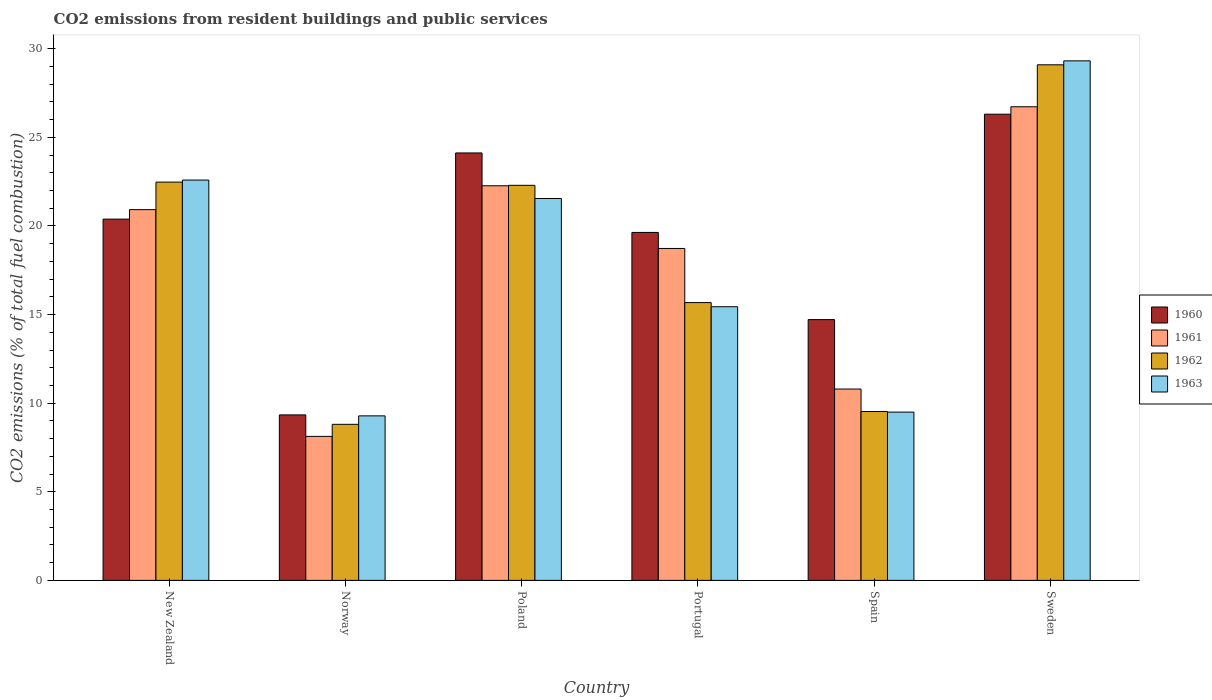Are the number of bars per tick equal to the number of legend labels?
Your answer should be very brief. Yes. Are the number of bars on each tick of the X-axis equal?
Make the answer very short. Yes. How many bars are there on the 6th tick from the right?
Your response must be concise. 4. What is the label of the 2nd group of bars from the left?
Keep it short and to the point. Norway. What is the total CO2 emitted in 1963 in Portugal?
Offer a terse response. 15.44. Across all countries, what is the maximum total CO2 emitted in 1963?
Provide a succinct answer. 29.32. Across all countries, what is the minimum total CO2 emitted in 1963?
Keep it short and to the point. 9.28. In which country was the total CO2 emitted in 1960 maximum?
Offer a terse response. Sweden. What is the total total CO2 emitted in 1962 in the graph?
Ensure brevity in your answer.  107.89. What is the difference between the total CO2 emitted in 1960 in Norway and that in Spain?
Keep it short and to the point. -5.38. What is the difference between the total CO2 emitted in 1962 in Sweden and the total CO2 emitted in 1960 in Poland?
Make the answer very short. 4.97. What is the average total CO2 emitted in 1962 per country?
Your answer should be very brief. 17.98. What is the difference between the total CO2 emitted of/in 1960 and total CO2 emitted of/in 1963 in Spain?
Ensure brevity in your answer.  5.22. In how many countries, is the total CO2 emitted in 1961 greater than 17?
Ensure brevity in your answer.  4. What is the ratio of the total CO2 emitted in 1960 in New Zealand to that in Poland?
Keep it short and to the point. 0.85. Is the difference between the total CO2 emitted in 1960 in New Zealand and Portugal greater than the difference between the total CO2 emitted in 1963 in New Zealand and Portugal?
Provide a short and direct response. No. What is the difference between the highest and the second highest total CO2 emitted in 1963?
Keep it short and to the point. -7.77. What is the difference between the highest and the lowest total CO2 emitted in 1960?
Your answer should be compact. 16.97. In how many countries, is the total CO2 emitted in 1961 greater than the average total CO2 emitted in 1961 taken over all countries?
Provide a short and direct response. 4. Is the sum of the total CO2 emitted in 1962 in Norway and Portugal greater than the maximum total CO2 emitted in 1960 across all countries?
Provide a succinct answer. No. Is it the case that in every country, the sum of the total CO2 emitted in 1960 and total CO2 emitted in 1963 is greater than the sum of total CO2 emitted in 1962 and total CO2 emitted in 1961?
Your response must be concise. No. What does the 4th bar from the left in Sweden represents?
Your answer should be very brief. 1963. What does the 1st bar from the right in Portugal represents?
Ensure brevity in your answer.  1963. How many countries are there in the graph?
Ensure brevity in your answer.  6. What is the difference between two consecutive major ticks on the Y-axis?
Make the answer very short. 5. Does the graph contain any zero values?
Keep it short and to the point. No. What is the title of the graph?
Keep it short and to the point. CO2 emissions from resident buildings and public services. What is the label or title of the X-axis?
Your answer should be very brief. Country. What is the label or title of the Y-axis?
Offer a very short reply. CO2 emissions (% of total fuel combustion). What is the CO2 emissions (% of total fuel combustion) in 1960 in New Zealand?
Your answer should be very brief. 20.39. What is the CO2 emissions (% of total fuel combustion) in 1961 in New Zealand?
Provide a succinct answer. 20.92. What is the CO2 emissions (% of total fuel combustion) of 1962 in New Zealand?
Give a very brief answer. 22.48. What is the CO2 emissions (% of total fuel combustion) in 1963 in New Zealand?
Make the answer very short. 22.59. What is the CO2 emissions (% of total fuel combustion) of 1960 in Norway?
Provide a short and direct response. 9.34. What is the CO2 emissions (% of total fuel combustion) of 1961 in Norway?
Keep it short and to the point. 8.13. What is the CO2 emissions (% of total fuel combustion) of 1962 in Norway?
Provide a succinct answer. 8.81. What is the CO2 emissions (% of total fuel combustion) in 1963 in Norway?
Offer a very short reply. 9.28. What is the CO2 emissions (% of total fuel combustion) of 1960 in Poland?
Offer a terse response. 24.12. What is the CO2 emissions (% of total fuel combustion) in 1961 in Poland?
Give a very brief answer. 22.27. What is the CO2 emissions (% of total fuel combustion) in 1962 in Poland?
Give a very brief answer. 22.3. What is the CO2 emissions (% of total fuel combustion) in 1963 in Poland?
Provide a succinct answer. 21.55. What is the CO2 emissions (% of total fuel combustion) in 1960 in Portugal?
Your answer should be compact. 19.64. What is the CO2 emissions (% of total fuel combustion) in 1961 in Portugal?
Your answer should be compact. 18.73. What is the CO2 emissions (% of total fuel combustion) in 1962 in Portugal?
Your answer should be very brief. 15.68. What is the CO2 emissions (% of total fuel combustion) in 1963 in Portugal?
Your answer should be compact. 15.44. What is the CO2 emissions (% of total fuel combustion) in 1960 in Spain?
Make the answer very short. 14.72. What is the CO2 emissions (% of total fuel combustion) in 1961 in Spain?
Your answer should be compact. 10.8. What is the CO2 emissions (% of total fuel combustion) in 1962 in Spain?
Keep it short and to the point. 9.53. What is the CO2 emissions (% of total fuel combustion) in 1963 in Spain?
Provide a succinct answer. 9.5. What is the CO2 emissions (% of total fuel combustion) of 1960 in Sweden?
Make the answer very short. 26.31. What is the CO2 emissions (% of total fuel combustion) of 1961 in Sweden?
Make the answer very short. 26.73. What is the CO2 emissions (% of total fuel combustion) in 1962 in Sweden?
Keep it short and to the point. 29.1. What is the CO2 emissions (% of total fuel combustion) of 1963 in Sweden?
Provide a succinct answer. 29.32. Across all countries, what is the maximum CO2 emissions (% of total fuel combustion) in 1960?
Make the answer very short. 26.31. Across all countries, what is the maximum CO2 emissions (% of total fuel combustion) in 1961?
Provide a short and direct response. 26.73. Across all countries, what is the maximum CO2 emissions (% of total fuel combustion) in 1962?
Your response must be concise. 29.1. Across all countries, what is the maximum CO2 emissions (% of total fuel combustion) of 1963?
Provide a short and direct response. 29.32. Across all countries, what is the minimum CO2 emissions (% of total fuel combustion) of 1960?
Your answer should be very brief. 9.34. Across all countries, what is the minimum CO2 emissions (% of total fuel combustion) of 1961?
Offer a very short reply. 8.13. Across all countries, what is the minimum CO2 emissions (% of total fuel combustion) of 1962?
Ensure brevity in your answer.  8.81. Across all countries, what is the minimum CO2 emissions (% of total fuel combustion) in 1963?
Give a very brief answer. 9.28. What is the total CO2 emissions (% of total fuel combustion) of 1960 in the graph?
Keep it short and to the point. 114.51. What is the total CO2 emissions (% of total fuel combustion) of 1961 in the graph?
Make the answer very short. 107.58. What is the total CO2 emissions (% of total fuel combustion) in 1962 in the graph?
Make the answer very short. 107.89. What is the total CO2 emissions (% of total fuel combustion) in 1963 in the graph?
Offer a very short reply. 107.69. What is the difference between the CO2 emissions (% of total fuel combustion) of 1960 in New Zealand and that in Norway?
Your answer should be very brief. 11.05. What is the difference between the CO2 emissions (% of total fuel combustion) of 1961 in New Zealand and that in Norway?
Your answer should be very brief. 12.8. What is the difference between the CO2 emissions (% of total fuel combustion) of 1962 in New Zealand and that in Norway?
Offer a terse response. 13.67. What is the difference between the CO2 emissions (% of total fuel combustion) of 1963 in New Zealand and that in Norway?
Provide a succinct answer. 13.31. What is the difference between the CO2 emissions (% of total fuel combustion) in 1960 in New Zealand and that in Poland?
Your answer should be compact. -3.73. What is the difference between the CO2 emissions (% of total fuel combustion) of 1961 in New Zealand and that in Poland?
Offer a terse response. -1.35. What is the difference between the CO2 emissions (% of total fuel combustion) in 1962 in New Zealand and that in Poland?
Provide a succinct answer. 0.18. What is the difference between the CO2 emissions (% of total fuel combustion) in 1963 in New Zealand and that in Poland?
Your answer should be very brief. 1.04. What is the difference between the CO2 emissions (% of total fuel combustion) of 1960 in New Zealand and that in Portugal?
Provide a succinct answer. 0.75. What is the difference between the CO2 emissions (% of total fuel combustion) in 1961 in New Zealand and that in Portugal?
Provide a succinct answer. 2.19. What is the difference between the CO2 emissions (% of total fuel combustion) of 1962 in New Zealand and that in Portugal?
Your answer should be compact. 6.8. What is the difference between the CO2 emissions (% of total fuel combustion) in 1963 in New Zealand and that in Portugal?
Make the answer very short. 7.15. What is the difference between the CO2 emissions (% of total fuel combustion) in 1960 in New Zealand and that in Spain?
Keep it short and to the point. 5.67. What is the difference between the CO2 emissions (% of total fuel combustion) in 1961 in New Zealand and that in Spain?
Your response must be concise. 10.13. What is the difference between the CO2 emissions (% of total fuel combustion) in 1962 in New Zealand and that in Spain?
Your answer should be compact. 12.95. What is the difference between the CO2 emissions (% of total fuel combustion) in 1963 in New Zealand and that in Spain?
Provide a short and direct response. 13.1. What is the difference between the CO2 emissions (% of total fuel combustion) in 1960 in New Zealand and that in Sweden?
Ensure brevity in your answer.  -5.92. What is the difference between the CO2 emissions (% of total fuel combustion) in 1961 in New Zealand and that in Sweden?
Ensure brevity in your answer.  -5.81. What is the difference between the CO2 emissions (% of total fuel combustion) in 1962 in New Zealand and that in Sweden?
Your response must be concise. -6.62. What is the difference between the CO2 emissions (% of total fuel combustion) of 1963 in New Zealand and that in Sweden?
Provide a short and direct response. -6.73. What is the difference between the CO2 emissions (% of total fuel combustion) of 1960 in Norway and that in Poland?
Provide a short and direct response. -14.78. What is the difference between the CO2 emissions (% of total fuel combustion) in 1961 in Norway and that in Poland?
Your answer should be very brief. -14.14. What is the difference between the CO2 emissions (% of total fuel combustion) in 1962 in Norway and that in Poland?
Offer a terse response. -13.49. What is the difference between the CO2 emissions (% of total fuel combustion) in 1963 in Norway and that in Poland?
Your answer should be very brief. -12.27. What is the difference between the CO2 emissions (% of total fuel combustion) in 1960 in Norway and that in Portugal?
Offer a terse response. -10.3. What is the difference between the CO2 emissions (% of total fuel combustion) of 1961 in Norway and that in Portugal?
Offer a very short reply. -10.61. What is the difference between the CO2 emissions (% of total fuel combustion) in 1962 in Norway and that in Portugal?
Provide a succinct answer. -6.87. What is the difference between the CO2 emissions (% of total fuel combustion) in 1963 in Norway and that in Portugal?
Give a very brief answer. -6.16. What is the difference between the CO2 emissions (% of total fuel combustion) of 1960 in Norway and that in Spain?
Your response must be concise. -5.38. What is the difference between the CO2 emissions (% of total fuel combustion) in 1961 in Norway and that in Spain?
Make the answer very short. -2.67. What is the difference between the CO2 emissions (% of total fuel combustion) of 1962 in Norway and that in Spain?
Your response must be concise. -0.72. What is the difference between the CO2 emissions (% of total fuel combustion) of 1963 in Norway and that in Spain?
Your response must be concise. -0.21. What is the difference between the CO2 emissions (% of total fuel combustion) in 1960 in Norway and that in Sweden?
Your answer should be very brief. -16.97. What is the difference between the CO2 emissions (% of total fuel combustion) in 1961 in Norway and that in Sweden?
Offer a very short reply. -18.6. What is the difference between the CO2 emissions (% of total fuel combustion) of 1962 in Norway and that in Sweden?
Your answer should be very brief. -20.29. What is the difference between the CO2 emissions (% of total fuel combustion) in 1963 in Norway and that in Sweden?
Ensure brevity in your answer.  -20.04. What is the difference between the CO2 emissions (% of total fuel combustion) of 1960 in Poland and that in Portugal?
Your answer should be very brief. 4.49. What is the difference between the CO2 emissions (% of total fuel combustion) of 1961 in Poland and that in Portugal?
Ensure brevity in your answer.  3.54. What is the difference between the CO2 emissions (% of total fuel combustion) in 1962 in Poland and that in Portugal?
Offer a terse response. 6.62. What is the difference between the CO2 emissions (% of total fuel combustion) in 1963 in Poland and that in Portugal?
Ensure brevity in your answer.  6.11. What is the difference between the CO2 emissions (% of total fuel combustion) of 1960 in Poland and that in Spain?
Make the answer very short. 9.41. What is the difference between the CO2 emissions (% of total fuel combustion) in 1961 in Poland and that in Spain?
Provide a short and direct response. 11.47. What is the difference between the CO2 emissions (% of total fuel combustion) in 1962 in Poland and that in Spain?
Provide a succinct answer. 12.76. What is the difference between the CO2 emissions (% of total fuel combustion) in 1963 in Poland and that in Spain?
Your answer should be very brief. 12.05. What is the difference between the CO2 emissions (% of total fuel combustion) in 1960 in Poland and that in Sweden?
Offer a very short reply. -2.19. What is the difference between the CO2 emissions (% of total fuel combustion) in 1961 in Poland and that in Sweden?
Ensure brevity in your answer.  -4.46. What is the difference between the CO2 emissions (% of total fuel combustion) of 1962 in Poland and that in Sweden?
Offer a very short reply. -6.8. What is the difference between the CO2 emissions (% of total fuel combustion) of 1963 in Poland and that in Sweden?
Offer a very short reply. -7.77. What is the difference between the CO2 emissions (% of total fuel combustion) of 1960 in Portugal and that in Spain?
Make the answer very short. 4.92. What is the difference between the CO2 emissions (% of total fuel combustion) of 1961 in Portugal and that in Spain?
Give a very brief answer. 7.93. What is the difference between the CO2 emissions (% of total fuel combustion) of 1962 in Portugal and that in Spain?
Offer a terse response. 6.15. What is the difference between the CO2 emissions (% of total fuel combustion) of 1963 in Portugal and that in Spain?
Your answer should be very brief. 5.95. What is the difference between the CO2 emissions (% of total fuel combustion) of 1960 in Portugal and that in Sweden?
Make the answer very short. -6.67. What is the difference between the CO2 emissions (% of total fuel combustion) of 1961 in Portugal and that in Sweden?
Offer a terse response. -8. What is the difference between the CO2 emissions (% of total fuel combustion) in 1962 in Portugal and that in Sweden?
Provide a succinct answer. -13.42. What is the difference between the CO2 emissions (% of total fuel combustion) of 1963 in Portugal and that in Sweden?
Your answer should be very brief. -13.88. What is the difference between the CO2 emissions (% of total fuel combustion) of 1960 in Spain and that in Sweden?
Your answer should be compact. -11.59. What is the difference between the CO2 emissions (% of total fuel combustion) of 1961 in Spain and that in Sweden?
Make the answer very short. -15.93. What is the difference between the CO2 emissions (% of total fuel combustion) in 1962 in Spain and that in Sweden?
Keep it short and to the point. -19.57. What is the difference between the CO2 emissions (% of total fuel combustion) of 1963 in Spain and that in Sweden?
Provide a short and direct response. -19.82. What is the difference between the CO2 emissions (% of total fuel combustion) in 1960 in New Zealand and the CO2 emissions (% of total fuel combustion) in 1961 in Norway?
Make the answer very short. 12.26. What is the difference between the CO2 emissions (% of total fuel combustion) in 1960 in New Zealand and the CO2 emissions (% of total fuel combustion) in 1962 in Norway?
Give a very brief answer. 11.58. What is the difference between the CO2 emissions (% of total fuel combustion) of 1960 in New Zealand and the CO2 emissions (% of total fuel combustion) of 1963 in Norway?
Ensure brevity in your answer.  11.1. What is the difference between the CO2 emissions (% of total fuel combustion) of 1961 in New Zealand and the CO2 emissions (% of total fuel combustion) of 1962 in Norway?
Keep it short and to the point. 12.12. What is the difference between the CO2 emissions (% of total fuel combustion) of 1961 in New Zealand and the CO2 emissions (% of total fuel combustion) of 1963 in Norway?
Offer a terse response. 11.64. What is the difference between the CO2 emissions (% of total fuel combustion) in 1962 in New Zealand and the CO2 emissions (% of total fuel combustion) in 1963 in Norway?
Make the answer very short. 13.19. What is the difference between the CO2 emissions (% of total fuel combustion) in 1960 in New Zealand and the CO2 emissions (% of total fuel combustion) in 1961 in Poland?
Make the answer very short. -1.88. What is the difference between the CO2 emissions (% of total fuel combustion) in 1960 in New Zealand and the CO2 emissions (% of total fuel combustion) in 1962 in Poland?
Keep it short and to the point. -1.91. What is the difference between the CO2 emissions (% of total fuel combustion) in 1960 in New Zealand and the CO2 emissions (% of total fuel combustion) in 1963 in Poland?
Provide a short and direct response. -1.16. What is the difference between the CO2 emissions (% of total fuel combustion) in 1961 in New Zealand and the CO2 emissions (% of total fuel combustion) in 1962 in Poland?
Offer a terse response. -1.37. What is the difference between the CO2 emissions (% of total fuel combustion) in 1961 in New Zealand and the CO2 emissions (% of total fuel combustion) in 1963 in Poland?
Offer a terse response. -0.63. What is the difference between the CO2 emissions (% of total fuel combustion) in 1962 in New Zealand and the CO2 emissions (% of total fuel combustion) in 1963 in Poland?
Ensure brevity in your answer.  0.93. What is the difference between the CO2 emissions (% of total fuel combustion) in 1960 in New Zealand and the CO2 emissions (% of total fuel combustion) in 1961 in Portugal?
Provide a succinct answer. 1.66. What is the difference between the CO2 emissions (% of total fuel combustion) of 1960 in New Zealand and the CO2 emissions (% of total fuel combustion) of 1962 in Portugal?
Provide a short and direct response. 4.71. What is the difference between the CO2 emissions (% of total fuel combustion) in 1960 in New Zealand and the CO2 emissions (% of total fuel combustion) in 1963 in Portugal?
Make the answer very short. 4.94. What is the difference between the CO2 emissions (% of total fuel combustion) in 1961 in New Zealand and the CO2 emissions (% of total fuel combustion) in 1962 in Portugal?
Provide a short and direct response. 5.25. What is the difference between the CO2 emissions (% of total fuel combustion) in 1961 in New Zealand and the CO2 emissions (% of total fuel combustion) in 1963 in Portugal?
Provide a succinct answer. 5.48. What is the difference between the CO2 emissions (% of total fuel combustion) in 1962 in New Zealand and the CO2 emissions (% of total fuel combustion) in 1963 in Portugal?
Keep it short and to the point. 7.03. What is the difference between the CO2 emissions (% of total fuel combustion) in 1960 in New Zealand and the CO2 emissions (% of total fuel combustion) in 1961 in Spain?
Give a very brief answer. 9.59. What is the difference between the CO2 emissions (% of total fuel combustion) in 1960 in New Zealand and the CO2 emissions (% of total fuel combustion) in 1962 in Spain?
Offer a very short reply. 10.86. What is the difference between the CO2 emissions (% of total fuel combustion) in 1960 in New Zealand and the CO2 emissions (% of total fuel combustion) in 1963 in Spain?
Offer a very short reply. 10.89. What is the difference between the CO2 emissions (% of total fuel combustion) in 1961 in New Zealand and the CO2 emissions (% of total fuel combustion) in 1962 in Spain?
Provide a succinct answer. 11.39. What is the difference between the CO2 emissions (% of total fuel combustion) in 1961 in New Zealand and the CO2 emissions (% of total fuel combustion) in 1963 in Spain?
Provide a short and direct response. 11.43. What is the difference between the CO2 emissions (% of total fuel combustion) in 1962 in New Zealand and the CO2 emissions (% of total fuel combustion) in 1963 in Spain?
Ensure brevity in your answer.  12.98. What is the difference between the CO2 emissions (% of total fuel combustion) in 1960 in New Zealand and the CO2 emissions (% of total fuel combustion) in 1961 in Sweden?
Keep it short and to the point. -6.34. What is the difference between the CO2 emissions (% of total fuel combustion) of 1960 in New Zealand and the CO2 emissions (% of total fuel combustion) of 1962 in Sweden?
Your answer should be very brief. -8.71. What is the difference between the CO2 emissions (% of total fuel combustion) of 1960 in New Zealand and the CO2 emissions (% of total fuel combustion) of 1963 in Sweden?
Offer a very short reply. -8.93. What is the difference between the CO2 emissions (% of total fuel combustion) of 1961 in New Zealand and the CO2 emissions (% of total fuel combustion) of 1962 in Sweden?
Provide a short and direct response. -8.17. What is the difference between the CO2 emissions (% of total fuel combustion) of 1961 in New Zealand and the CO2 emissions (% of total fuel combustion) of 1963 in Sweden?
Your answer should be compact. -8.4. What is the difference between the CO2 emissions (% of total fuel combustion) in 1962 in New Zealand and the CO2 emissions (% of total fuel combustion) in 1963 in Sweden?
Provide a short and direct response. -6.84. What is the difference between the CO2 emissions (% of total fuel combustion) of 1960 in Norway and the CO2 emissions (% of total fuel combustion) of 1961 in Poland?
Ensure brevity in your answer.  -12.93. What is the difference between the CO2 emissions (% of total fuel combustion) in 1960 in Norway and the CO2 emissions (% of total fuel combustion) in 1962 in Poland?
Provide a succinct answer. -12.96. What is the difference between the CO2 emissions (% of total fuel combustion) of 1960 in Norway and the CO2 emissions (% of total fuel combustion) of 1963 in Poland?
Your answer should be very brief. -12.21. What is the difference between the CO2 emissions (% of total fuel combustion) of 1961 in Norway and the CO2 emissions (% of total fuel combustion) of 1962 in Poland?
Make the answer very short. -14.17. What is the difference between the CO2 emissions (% of total fuel combustion) of 1961 in Norway and the CO2 emissions (% of total fuel combustion) of 1963 in Poland?
Keep it short and to the point. -13.42. What is the difference between the CO2 emissions (% of total fuel combustion) of 1962 in Norway and the CO2 emissions (% of total fuel combustion) of 1963 in Poland?
Your response must be concise. -12.74. What is the difference between the CO2 emissions (% of total fuel combustion) in 1960 in Norway and the CO2 emissions (% of total fuel combustion) in 1961 in Portugal?
Keep it short and to the point. -9.39. What is the difference between the CO2 emissions (% of total fuel combustion) in 1960 in Norway and the CO2 emissions (% of total fuel combustion) in 1962 in Portugal?
Offer a very short reply. -6.34. What is the difference between the CO2 emissions (% of total fuel combustion) in 1960 in Norway and the CO2 emissions (% of total fuel combustion) in 1963 in Portugal?
Provide a short and direct response. -6.1. What is the difference between the CO2 emissions (% of total fuel combustion) of 1961 in Norway and the CO2 emissions (% of total fuel combustion) of 1962 in Portugal?
Provide a succinct answer. -7.55. What is the difference between the CO2 emissions (% of total fuel combustion) in 1961 in Norway and the CO2 emissions (% of total fuel combustion) in 1963 in Portugal?
Your answer should be compact. -7.32. What is the difference between the CO2 emissions (% of total fuel combustion) of 1962 in Norway and the CO2 emissions (% of total fuel combustion) of 1963 in Portugal?
Your answer should be compact. -6.64. What is the difference between the CO2 emissions (% of total fuel combustion) of 1960 in Norway and the CO2 emissions (% of total fuel combustion) of 1961 in Spain?
Ensure brevity in your answer.  -1.46. What is the difference between the CO2 emissions (% of total fuel combustion) of 1960 in Norway and the CO2 emissions (% of total fuel combustion) of 1962 in Spain?
Your response must be concise. -0.19. What is the difference between the CO2 emissions (% of total fuel combustion) in 1960 in Norway and the CO2 emissions (% of total fuel combustion) in 1963 in Spain?
Provide a short and direct response. -0.16. What is the difference between the CO2 emissions (% of total fuel combustion) in 1961 in Norway and the CO2 emissions (% of total fuel combustion) in 1962 in Spain?
Your response must be concise. -1.4. What is the difference between the CO2 emissions (% of total fuel combustion) in 1961 in Norway and the CO2 emissions (% of total fuel combustion) in 1963 in Spain?
Offer a terse response. -1.37. What is the difference between the CO2 emissions (% of total fuel combustion) in 1962 in Norway and the CO2 emissions (% of total fuel combustion) in 1963 in Spain?
Your response must be concise. -0.69. What is the difference between the CO2 emissions (% of total fuel combustion) of 1960 in Norway and the CO2 emissions (% of total fuel combustion) of 1961 in Sweden?
Ensure brevity in your answer.  -17.39. What is the difference between the CO2 emissions (% of total fuel combustion) in 1960 in Norway and the CO2 emissions (% of total fuel combustion) in 1962 in Sweden?
Your answer should be compact. -19.76. What is the difference between the CO2 emissions (% of total fuel combustion) of 1960 in Norway and the CO2 emissions (% of total fuel combustion) of 1963 in Sweden?
Make the answer very short. -19.98. What is the difference between the CO2 emissions (% of total fuel combustion) in 1961 in Norway and the CO2 emissions (% of total fuel combustion) in 1962 in Sweden?
Provide a succinct answer. -20.97. What is the difference between the CO2 emissions (% of total fuel combustion) in 1961 in Norway and the CO2 emissions (% of total fuel combustion) in 1963 in Sweden?
Ensure brevity in your answer.  -21.19. What is the difference between the CO2 emissions (% of total fuel combustion) in 1962 in Norway and the CO2 emissions (% of total fuel combustion) in 1963 in Sweden?
Provide a succinct answer. -20.51. What is the difference between the CO2 emissions (% of total fuel combustion) in 1960 in Poland and the CO2 emissions (% of total fuel combustion) in 1961 in Portugal?
Ensure brevity in your answer.  5.39. What is the difference between the CO2 emissions (% of total fuel combustion) in 1960 in Poland and the CO2 emissions (% of total fuel combustion) in 1962 in Portugal?
Your answer should be very brief. 8.44. What is the difference between the CO2 emissions (% of total fuel combustion) in 1960 in Poland and the CO2 emissions (% of total fuel combustion) in 1963 in Portugal?
Your response must be concise. 8.68. What is the difference between the CO2 emissions (% of total fuel combustion) of 1961 in Poland and the CO2 emissions (% of total fuel combustion) of 1962 in Portugal?
Provide a succinct answer. 6.59. What is the difference between the CO2 emissions (% of total fuel combustion) of 1961 in Poland and the CO2 emissions (% of total fuel combustion) of 1963 in Portugal?
Ensure brevity in your answer.  6.83. What is the difference between the CO2 emissions (% of total fuel combustion) in 1962 in Poland and the CO2 emissions (% of total fuel combustion) in 1963 in Portugal?
Ensure brevity in your answer.  6.85. What is the difference between the CO2 emissions (% of total fuel combustion) of 1960 in Poland and the CO2 emissions (% of total fuel combustion) of 1961 in Spain?
Your answer should be compact. 13.32. What is the difference between the CO2 emissions (% of total fuel combustion) in 1960 in Poland and the CO2 emissions (% of total fuel combustion) in 1962 in Spain?
Make the answer very short. 14.59. What is the difference between the CO2 emissions (% of total fuel combustion) of 1960 in Poland and the CO2 emissions (% of total fuel combustion) of 1963 in Spain?
Offer a very short reply. 14.63. What is the difference between the CO2 emissions (% of total fuel combustion) of 1961 in Poland and the CO2 emissions (% of total fuel combustion) of 1962 in Spain?
Make the answer very short. 12.74. What is the difference between the CO2 emissions (% of total fuel combustion) of 1961 in Poland and the CO2 emissions (% of total fuel combustion) of 1963 in Spain?
Your answer should be very brief. 12.77. What is the difference between the CO2 emissions (% of total fuel combustion) of 1962 in Poland and the CO2 emissions (% of total fuel combustion) of 1963 in Spain?
Offer a terse response. 12.8. What is the difference between the CO2 emissions (% of total fuel combustion) of 1960 in Poland and the CO2 emissions (% of total fuel combustion) of 1961 in Sweden?
Provide a short and direct response. -2.61. What is the difference between the CO2 emissions (% of total fuel combustion) of 1960 in Poland and the CO2 emissions (% of total fuel combustion) of 1962 in Sweden?
Provide a short and direct response. -4.97. What is the difference between the CO2 emissions (% of total fuel combustion) of 1960 in Poland and the CO2 emissions (% of total fuel combustion) of 1963 in Sweden?
Offer a terse response. -5.2. What is the difference between the CO2 emissions (% of total fuel combustion) in 1961 in Poland and the CO2 emissions (% of total fuel combustion) in 1962 in Sweden?
Your response must be concise. -6.83. What is the difference between the CO2 emissions (% of total fuel combustion) of 1961 in Poland and the CO2 emissions (% of total fuel combustion) of 1963 in Sweden?
Your response must be concise. -7.05. What is the difference between the CO2 emissions (% of total fuel combustion) of 1962 in Poland and the CO2 emissions (% of total fuel combustion) of 1963 in Sweden?
Your answer should be compact. -7.02. What is the difference between the CO2 emissions (% of total fuel combustion) of 1960 in Portugal and the CO2 emissions (% of total fuel combustion) of 1961 in Spain?
Your answer should be very brief. 8.84. What is the difference between the CO2 emissions (% of total fuel combustion) in 1960 in Portugal and the CO2 emissions (% of total fuel combustion) in 1962 in Spain?
Your response must be concise. 10.11. What is the difference between the CO2 emissions (% of total fuel combustion) in 1960 in Portugal and the CO2 emissions (% of total fuel combustion) in 1963 in Spain?
Provide a short and direct response. 10.14. What is the difference between the CO2 emissions (% of total fuel combustion) in 1961 in Portugal and the CO2 emissions (% of total fuel combustion) in 1962 in Spain?
Give a very brief answer. 9.2. What is the difference between the CO2 emissions (% of total fuel combustion) in 1961 in Portugal and the CO2 emissions (% of total fuel combustion) in 1963 in Spain?
Give a very brief answer. 9.23. What is the difference between the CO2 emissions (% of total fuel combustion) of 1962 in Portugal and the CO2 emissions (% of total fuel combustion) of 1963 in Spain?
Offer a terse response. 6.18. What is the difference between the CO2 emissions (% of total fuel combustion) in 1960 in Portugal and the CO2 emissions (% of total fuel combustion) in 1961 in Sweden?
Ensure brevity in your answer.  -7.09. What is the difference between the CO2 emissions (% of total fuel combustion) in 1960 in Portugal and the CO2 emissions (% of total fuel combustion) in 1962 in Sweden?
Your response must be concise. -9.46. What is the difference between the CO2 emissions (% of total fuel combustion) of 1960 in Portugal and the CO2 emissions (% of total fuel combustion) of 1963 in Sweden?
Your answer should be very brief. -9.68. What is the difference between the CO2 emissions (% of total fuel combustion) in 1961 in Portugal and the CO2 emissions (% of total fuel combustion) in 1962 in Sweden?
Give a very brief answer. -10.36. What is the difference between the CO2 emissions (% of total fuel combustion) of 1961 in Portugal and the CO2 emissions (% of total fuel combustion) of 1963 in Sweden?
Provide a succinct answer. -10.59. What is the difference between the CO2 emissions (% of total fuel combustion) of 1962 in Portugal and the CO2 emissions (% of total fuel combustion) of 1963 in Sweden?
Your answer should be very brief. -13.64. What is the difference between the CO2 emissions (% of total fuel combustion) in 1960 in Spain and the CO2 emissions (% of total fuel combustion) in 1961 in Sweden?
Provide a succinct answer. -12.01. What is the difference between the CO2 emissions (% of total fuel combustion) in 1960 in Spain and the CO2 emissions (% of total fuel combustion) in 1962 in Sweden?
Offer a very short reply. -14.38. What is the difference between the CO2 emissions (% of total fuel combustion) of 1960 in Spain and the CO2 emissions (% of total fuel combustion) of 1963 in Sweden?
Give a very brief answer. -14.6. What is the difference between the CO2 emissions (% of total fuel combustion) in 1961 in Spain and the CO2 emissions (% of total fuel combustion) in 1962 in Sweden?
Your answer should be very brief. -18.3. What is the difference between the CO2 emissions (% of total fuel combustion) of 1961 in Spain and the CO2 emissions (% of total fuel combustion) of 1963 in Sweden?
Offer a very short reply. -18.52. What is the difference between the CO2 emissions (% of total fuel combustion) of 1962 in Spain and the CO2 emissions (% of total fuel combustion) of 1963 in Sweden?
Your response must be concise. -19.79. What is the average CO2 emissions (% of total fuel combustion) in 1960 per country?
Offer a very short reply. 19.09. What is the average CO2 emissions (% of total fuel combustion) in 1961 per country?
Make the answer very short. 17.93. What is the average CO2 emissions (% of total fuel combustion) in 1962 per country?
Ensure brevity in your answer.  17.98. What is the average CO2 emissions (% of total fuel combustion) in 1963 per country?
Your answer should be compact. 17.95. What is the difference between the CO2 emissions (% of total fuel combustion) of 1960 and CO2 emissions (% of total fuel combustion) of 1961 in New Zealand?
Make the answer very short. -0.54. What is the difference between the CO2 emissions (% of total fuel combustion) of 1960 and CO2 emissions (% of total fuel combustion) of 1962 in New Zealand?
Your response must be concise. -2.09. What is the difference between the CO2 emissions (% of total fuel combustion) in 1960 and CO2 emissions (% of total fuel combustion) in 1963 in New Zealand?
Provide a succinct answer. -2.2. What is the difference between the CO2 emissions (% of total fuel combustion) in 1961 and CO2 emissions (% of total fuel combustion) in 1962 in New Zealand?
Keep it short and to the point. -1.55. What is the difference between the CO2 emissions (% of total fuel combustion) of 1961 and CO2 emissions (% of total fuel combustion) of 1963 in New Zealand?
Keep it short and to the point. -1.67. What is the difference between the CO2 emissions (% of total fuel combustion) in 1962 and CO2 emissions (% of total fuel combustion) in 1963 in New Zealand?
Make the answer very short. -0.12. What is the difference between the CO2 emissions (% of total fuel combustion) of 1960 and CO2 emissions (% of total fuel combustion) of 1961 in Norway?
Your response must be concise. 1.21. What is the difference between the CO2 emissions (% of total fuel combustion) in 1960 and CO2 emissions (% of total fuel combustion) in 1962 in Norway?
Ensure brevity in your answer.  0.53. What is the difference between the CO2 emissions (% of total fuel combustion) in 1960 and CO2 emissions (% of total fuel combustion) in 1963 in Norway?
Your answer should be very brief. 0.05. What is the difference between the CO2 emissions (% of total fuel combustion) in 1961 and CO2 emissions (% of total fuel combustion) in 1962 in Norway?
Your answer should be compact. -0.68. What is the difference between the CO2 emissions (% of total fuel combustion) of 1961 and CO2 emissions (% of total fuel combustion) of 1963 in Norway?
Provide a succinct answer. -1.16. What is the difference between the CO2 emissions (% of total fuel combustion) in 1962 and CO2 emissions (% of total fuel combustion) in 1963 in Norway?
Your response must be concise. -0.48. What is the difference between the CO2 emissions (% of total fuel combustion) of 1960 and CO2 emissions (% of total fuel combustion) of 1961 in Poland?
Offer a very short reply. 1.85. What is the difference between the CO2 emissions (% of total fuel combustion) of 1960 and CO2 emissions (% of total fuel combustion) of 1962 in Poland?
Your answer should be very brief. 1.83. What is the difference between the CO2 emissions (% of total fuel combustion) in 1960 and CO2 emissions (% of total fuel combustion) in 1963 in Poland?
Keep it short and to the point. 2.57. What is the difference between the CO2 emissions (% of total fuel combustion) of 1961 and CO2 emissions (% of total fuel combustion) of 1962 in Poland?
Give a very brief answer. -0.02. What is the difference between the CO2 emissions (% of total fuel combustion) in 1961 and CO2 emissions (% of total fuel combustion) in 1963 in Poland?
Make the answer very short. 0.72. What is the difference between the CO2 emissions (% of total fuel combustion) of 1962 and CO2 emissions (% of total fuel combustion) of 1963 in Poland?
Offer a terse response. 0.74. What is the difference between the CO2 emissions (% of total fuel combustion) in 1960 and CO2 emissions (% of total fuel combustion) in 1961 in Portugal?
Your answer should be very brief. 0.91. What is the difference between the CO2 emissions (% of total fuel combustion) in 1960 and CO2 emissions (% of total fuel combustion) in 1962 in Portugal?
Offer a very short reply. 3.96. What is the difference between the CO2 emissions (% of total fuel combustion) in 1960 and CO2 emissions (% of total fuel combustion) in 1963 in Portugal?
Your answer should be compact. 4.19. What is the difference between the CO2 emissions (% of total fuel combustion) of 1961 and CO2 emissions (% of total fuel combustion) of 1962 in Portugal?
Your answer should be compact. 3.05. What is the difference between the CO2 emissions (% of total fuel combustion) of 1961 and CO2 emissions (% of total fuel combustion) of 1963 in Portugal?
Provide a succinct answer. 3.29. What is the difference between the CO2 emissions (% of total fuel combustion) of 1962 and CO2 emissions (% of total fuel combustion) of 1963 in Portugal?
Ensure brevity in your answer.  0.23. What is the difference between the CO2 emissions (% of total fuel combustion) of 1960 and CO2 emissions (% of total fuel combustion) of 1961 in Spain?
Your answer should be compact. 3.92. What is the difference between the CO2 emissions (% of total fuel combustion) in 1960 and CO2 emissions (% of total fuel combustion) in 1962 in Spain?
Make the answer very short. 5.19. What is the difference between the CO2 emissions (% of total fuel combustion) in 1960 and CO2 emissions (% of total fuel combustion) in 1963 in Spain?
Your answer should be very brief. 5.22. What is the difference between the CO2 emissions (% of total fuel combustion) of 1961 and CO2 emissions (% of total fuel combustion) of 1962 in Spain?
Offer a terse response. 1.27. What is the difference between the CO2 emissions (% of total fuel combustion) in 1961 and CO2 emissions (% of total fuel combustion) in 1963 in Spain?
Give a very brief answer. 1.3. What is the difference between the CO2 emissions (% of total fuel combustion) of 1962 and CO2 emissions (% of total fuel combustion) of 1963 in Spain?
Your answer should be compact. 0.03. What is the difference between the CO2 emissions (% of total fuel combustion) of 1960 and CO2 emissions (% of total fuel combustion) of 1961 in Sweden?
Give a very brief answer. -0.42. What is the difference between the CO2 emissions (% of total fuel combustion) of 1960 and CO2 emissions (% of total fuel combustion) of 1962 in Sweden?
Your answer should be very brief. -2.79. What is the difference between the CO2 emissions (% of total fuel combustion) in 1960 and CO2 emissions (% of total fuel combustion) in 1963 in Sweden?
Ensure brevity in your answer.  -3.01. What is the difference between the CO2 emissions (% of total fuel combustion) of 1961 and CO2 emissions (% of total fuel combustion) of 1962 in Sweden?
Your response must be concise. -2.37. What is the difference between the CO2 emissions (% of total fuel combustion) in 1961 and CO2 emissions (% of total fuel combustion) in 1963 in Sweden?
Provide a succinct answer. -2.59. What is the difference between the CO2 emissions (% of total fuel combustion) in 1962 and CO2 emissions (% of total fuel combustion) in 1963 in Sweden?
Make the answer very short. -0.22. What is the ratio of the CO2 emissions (% of total fuel combustion) in 1960 in New Zealand to that in Norway?
Make the answer very short. 2.18. What is the ratio of the CO2 emissions (% of total fuel combustion) of 1961 in New Zealand to that in Norway?
Your answer should be compact. 2.57. What is the ratio of the CO2 emissions (% of total fuel combustion) in 1962 in New Zealand to that in Norway?
Your answer should be compact. 2.55. What is the ratio of the CO2 emissions (% of total fuel combustion) of 1963 in New Zealand to that in Norway?
Make the answer very short. 2.43. What is the ratio of the CO2 emissions (% of total fuel combustion) of 1960 in New Zealand to that in Poland?
Offer a very short reply. 0.85. What is the ratio of the CO2 emissions (% of total fuel combustion) in 1961 in New Zealand to that in Poland?
Make the answer very short. 0.94. What is the ratio of the CO2 emissions (% of total fuel combustion) of 1962 in New Zealand to that in Poland?
Your response must be concise. 1.01. What is the ratio of the CO2 emissions (% of total fuel combustion) of 1963 in New Zealand to that in Poland?
Offer a terse response. 1.05. What is the ratio of the CO2 emissions (% of total fuel combustion) of 1960 in New Zealand to that in Portugal?
Keep it short and to the point. 1.04. What is the ratio of the CO2 emissions (% of total fuel combustion) of 1961 in New Zealand to that in Portugal?
Give a very brief answer. 1.12. What is the ratio of the CO2 emissions (% of total fuel combustion) in 1962 in New Zealand to that in Portugal?
Your answer should be compact. 1.43. What is the ratio of the CO2 emissions (% of total fuel combustion) in 1963 in New Zealand to that in Portugal?
Make the answer very short. 1.46. What is the ratio of the CO2 emissions (% of total fuel combustion) in 1960 in New Zealand to that in Spain?
Your answer should be compact. 1.39. What is the ratio of the CO2 emissions (% of total fuel combustion) of 1961 in New Zealand to that in Spain?
Provide a short and direct response. 1.94. What is the ratio of the CO2 emissions (% of total fuel combustion) of 1962 in New Zealand to that in Spain?
Offer a very short reply. 2.36. What is the ratio of the CO2 emissions (% of total fuel combustion) in 1963 in New Zealand to that in Spain?
Your answer should be compact. 2.38. What is the ratio of the CO2 emissions (% of total fuel combustion) in 1960 in New Zealand to that in Sweden?
Your answer should be compact. 0.78. What is the ratio of the CO2 emissions (% of total fuel combustion) in 1961 in New Zealand to that in Sweden?
Offer a terse response. 0.78. What is the ratio of the CO2 emissions (% of total fuel combustion) of 1962 in New Zealand to that in Sweden?
Keep it short and to the point. 0.77. What is the ratio of the CO2 emissions (% of total fuel combustion) of 1963 in New Zealand to that in Sweden?
Your answer should be compact. 0.77. What is the ratio of the CO2 emissions (% of total fuel combustion) of 1960 in Norway to that in Poland?
Offer a very short reply. 0.39. What is the ratio of the CO2 emissions (% of total fuel combustion) of 1961 in Norway to that in Poland?
Your answer should be compact. 0.36. What is the ratio of the CO2 emissions (% of total fuel combustion) of 1962 in Norway to that in Poland?
Your answer should be very brief. 0.4. What is the ratio of the CO2 emissions (% of total fuel combustion) of 1963 in Norway to that in Poland?
Offer a very short reply. 0.43. What is the ratio of the CO2 emissions (% of total fuel combustion) of 1960 in Norway to that in Portugal?
Provide a short and direct response. 0.48. What is the ratio of the CO2 emissions (% of total fuel combustion) of 1961 in Norway to that in Portugal?
Your answer should be very brief. 0.43. What is the ratio of the CO2 emissions (% of total fuel combustion) of 1962 in Norway to that in Portugal?
Your answer should be compact. 0.56. What is the ratio of the CO2 emissions (% of total fuel combustion) in 1963 in Norway to that in Portugal?
Provide a short and direct response. 0.6. What is the ratio of the CO2 emissions (% of total fuel combustion) in 1960 in Norway to that in Spain?
Make the answer very short. 0.63. What is the ratio of the CO2 emissions (% of total fuel combustion) in 1961 in Norway to that in Spain?
Offer a very short reply. 0.75. What is the ratio of the CO2 emissions (% of total fuel combustion) in 1962 in Norway to that in Spain?
Ensure brevity in your answer.  0.92. What is the ratio of the CO2 emissions (% of total fuel combustion) of 1963 in Norway to that in Spain?
Make the answer very short. 0.98. What is the ratio of the CO2 emissions (% of total fuel combustion) of 1960 in Norway to that in Sweden?
Your answer should be compact. 0.35. What is the ratio of the CO2 emissions (% of total fuel combustion) of 1961 in Norway to that in Sweden?
Provide a short and direct response. 0.3. What is the ratio of the CO2 emissions (% of total fuel combustion) in 1962 in Norway to that in Sweden?
Your answer should be compact. 0.3. What is the ratio of the CO2 emissions (% of total fuel combustion) of 1963 in Norway to that in Sweden?
Make the answer very short. 0.32. What is the ratio of the CO2 emissions (% of total fuel combustion) of 1960 in Poland to that in Portugal?
Make the answer very short. 1.23. What is the ratio of the CO2 emissions (% of total fuel combustion) of 1961 in Poland to that in Portugal?
Provide a short and direct response. 1.19. What is the ratio of the CO2 emissions (% of total fuel combustion) of 1962 in Poland to that in Portugal?
Ensure brevity in your answer.  1.42. What is the ratio of the CO2 emissions (% of total fuel combustion) of 1963 in Poland to that in Portugal?
Offer a terse response. 1.4. What is the ratio of the CO2 emissions (% of total fuel combustion) of 1960 in Poland to that in Spain?
Your answer should be very brief. 1.64. What is the ratio of the CO2 emissions (% of total fuel combustion) in 1961 in Poland to that in Spain?
Provide a short and direct response. 2.06. What is the ratio of the CO2 emissions (% of total fuel combustion) of 1962 in Poland to that in Spain?
Keep it short and to the point. 2.34. What is the ratio of the CO2 emissions (% of total fuel combustion) of 1963 in Poland to that in Spain?
Ensure brevity in your answer.  2.27. What is the ratio of the CO2 emissions (% of total fuel combustion) in 1960 in Poland to that in Sweden?
Your answer should be very brief. 0.92. What is the ratio of the CO2 emissions (% of total fuel combustion) in 1961 in Poland to that in Sweden?
Make the answer very short. 0.83. What is the ratio of the CO2 emissions (% of total fuel combustion) of 1962 in Poland to that in Sweden?
Offer a very short reply. 0.77. What is the ratio of the CO2 emissions (% of total fuel combustion) of 1963 in Poland to that in Sweden?
Offer a terse response. 0.73. What is the ratio of the CO2 emissions (% of total fuel combustion) of 1960 in Portugal to that in Spain?
Your response must be concise. 1.33. What is the ratio of the CO2 emissions (% of total fuel combustion) in 1961 in Portugal to that in Spain?
Your response must be concise. 1.73. What is the ratio of the CO2 emissions (% of total fuel combustion) of 1962 in Portugal to that in Spain?
Your response must be concise. 1.64. What is the ratio of the CO2 emissions (% of total fuel combustion) in 1963 in Portugal to that in Spain?
Offer a terse response. 1.63. What is the ratio of the CO2 emissions (% of total fuel combustion) of 1960 in Portugal to that in Sweden?
Offer a very short reply. 0.75. What is the ratio of the CO2 emissions (% of total fuel combustion) in 1961 in Portugal to that in Sweden?
Provide a succinct answer. 0.7. What is the ratio of the CO2 emissions (% of total fuel combustion) in 1962 in Portugal to that in Sweden?
Keep it short and to the point. 0.54. What is the ratio of the CO2 emissions (% of total fuel combustion) in 1963 in Portugal to that in Sweden?
Your response must be concise. 0.53. What is the ratio of the CO2 emissions (% of total fuel combustion) in 1960 in Spain to that in Sweden?
Ensure brevity in your answer.  0.56. What is the ratio of the CO2 emissions (% of total fuel combustion) in 1961 in Spain to that in Sweden?
Provide a succinct answer. 0.4. What is the ratio of the CO2 emissions (% of total fuel combustion) of 1962 in Spain to that in Sweden?
Give a very brief answer. 0.33. What is the ratio of the CO2 emissions (% of total fuel combustion) of 1963 in Spain to that in Sweden?
Provide a succinct answer. 0.32. What is the difference between the highest and the second highest CO2 emissions (% of total fuel combustion) of 1960?
Your response must be concise. 2.19. What is the difference between the highest and the second highest CO2 emissions (% of total fuel combustion) of 1961?
Your answer should be very brief. 4.46. What is the difference between the highest and the second highest CO2 emissions (% of total fuel combustion) of 1962?
Offer a very short reply. 6.62. What is the difference between the highest and the second highest CO2 emissions (% of total fuel combustion) of 1963?
Offer a very short reply. 6.73. What is the difference between the highest and the lowest CO2 emissions (% of total fuel combustion) of 1960?
Ensure brevity in your answer.  16.97. What is the difference between the highest and the lowest CO2 emissions (% of total fuel combustion) of 1961?
Your answer should be very brief. 18.6. What is the difference between the highest and the lowest CO2 emissions (% of total fuel combustion) of 1962?
Your response must be concise. 20.29. What is the difference between the highest and the lowest CO2 emissions (% of total fuel combustion) of 1963?
Offer a terse response. 20.04. 